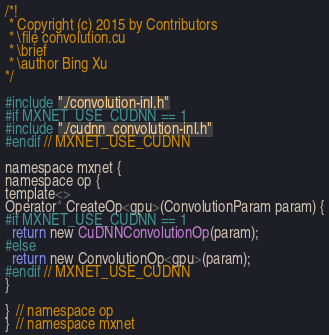Convert code to text. <code><loc_0><loc_0><loc_500><loc_500><_Cuda_>/*!
 * Copyright (c) 2015 by Contributors
 * \file convolution.cu
 * \brief
 * \author Bing Xu
*/

#include "./convolution-inl.h"
#if MXNET_USE_CUDNN == 1
#include "./cudnn_convolution-inl.h"
#endif // MXNET_USE_CUDNN

namespace mxnet {
namespace op {
template<>
Operator* CreateOp<gpu>(ConvolutionParam param) {
#if MXNET_USE_CUDNN == 1
  return new CuDNNConvolutionOp(param);
#else
  return new ConvolutionOp<gpu>(param);
#endif // MXNET_USE_CUDNN
}

}  // namespace op
}  // namespace mxnet

</code> 